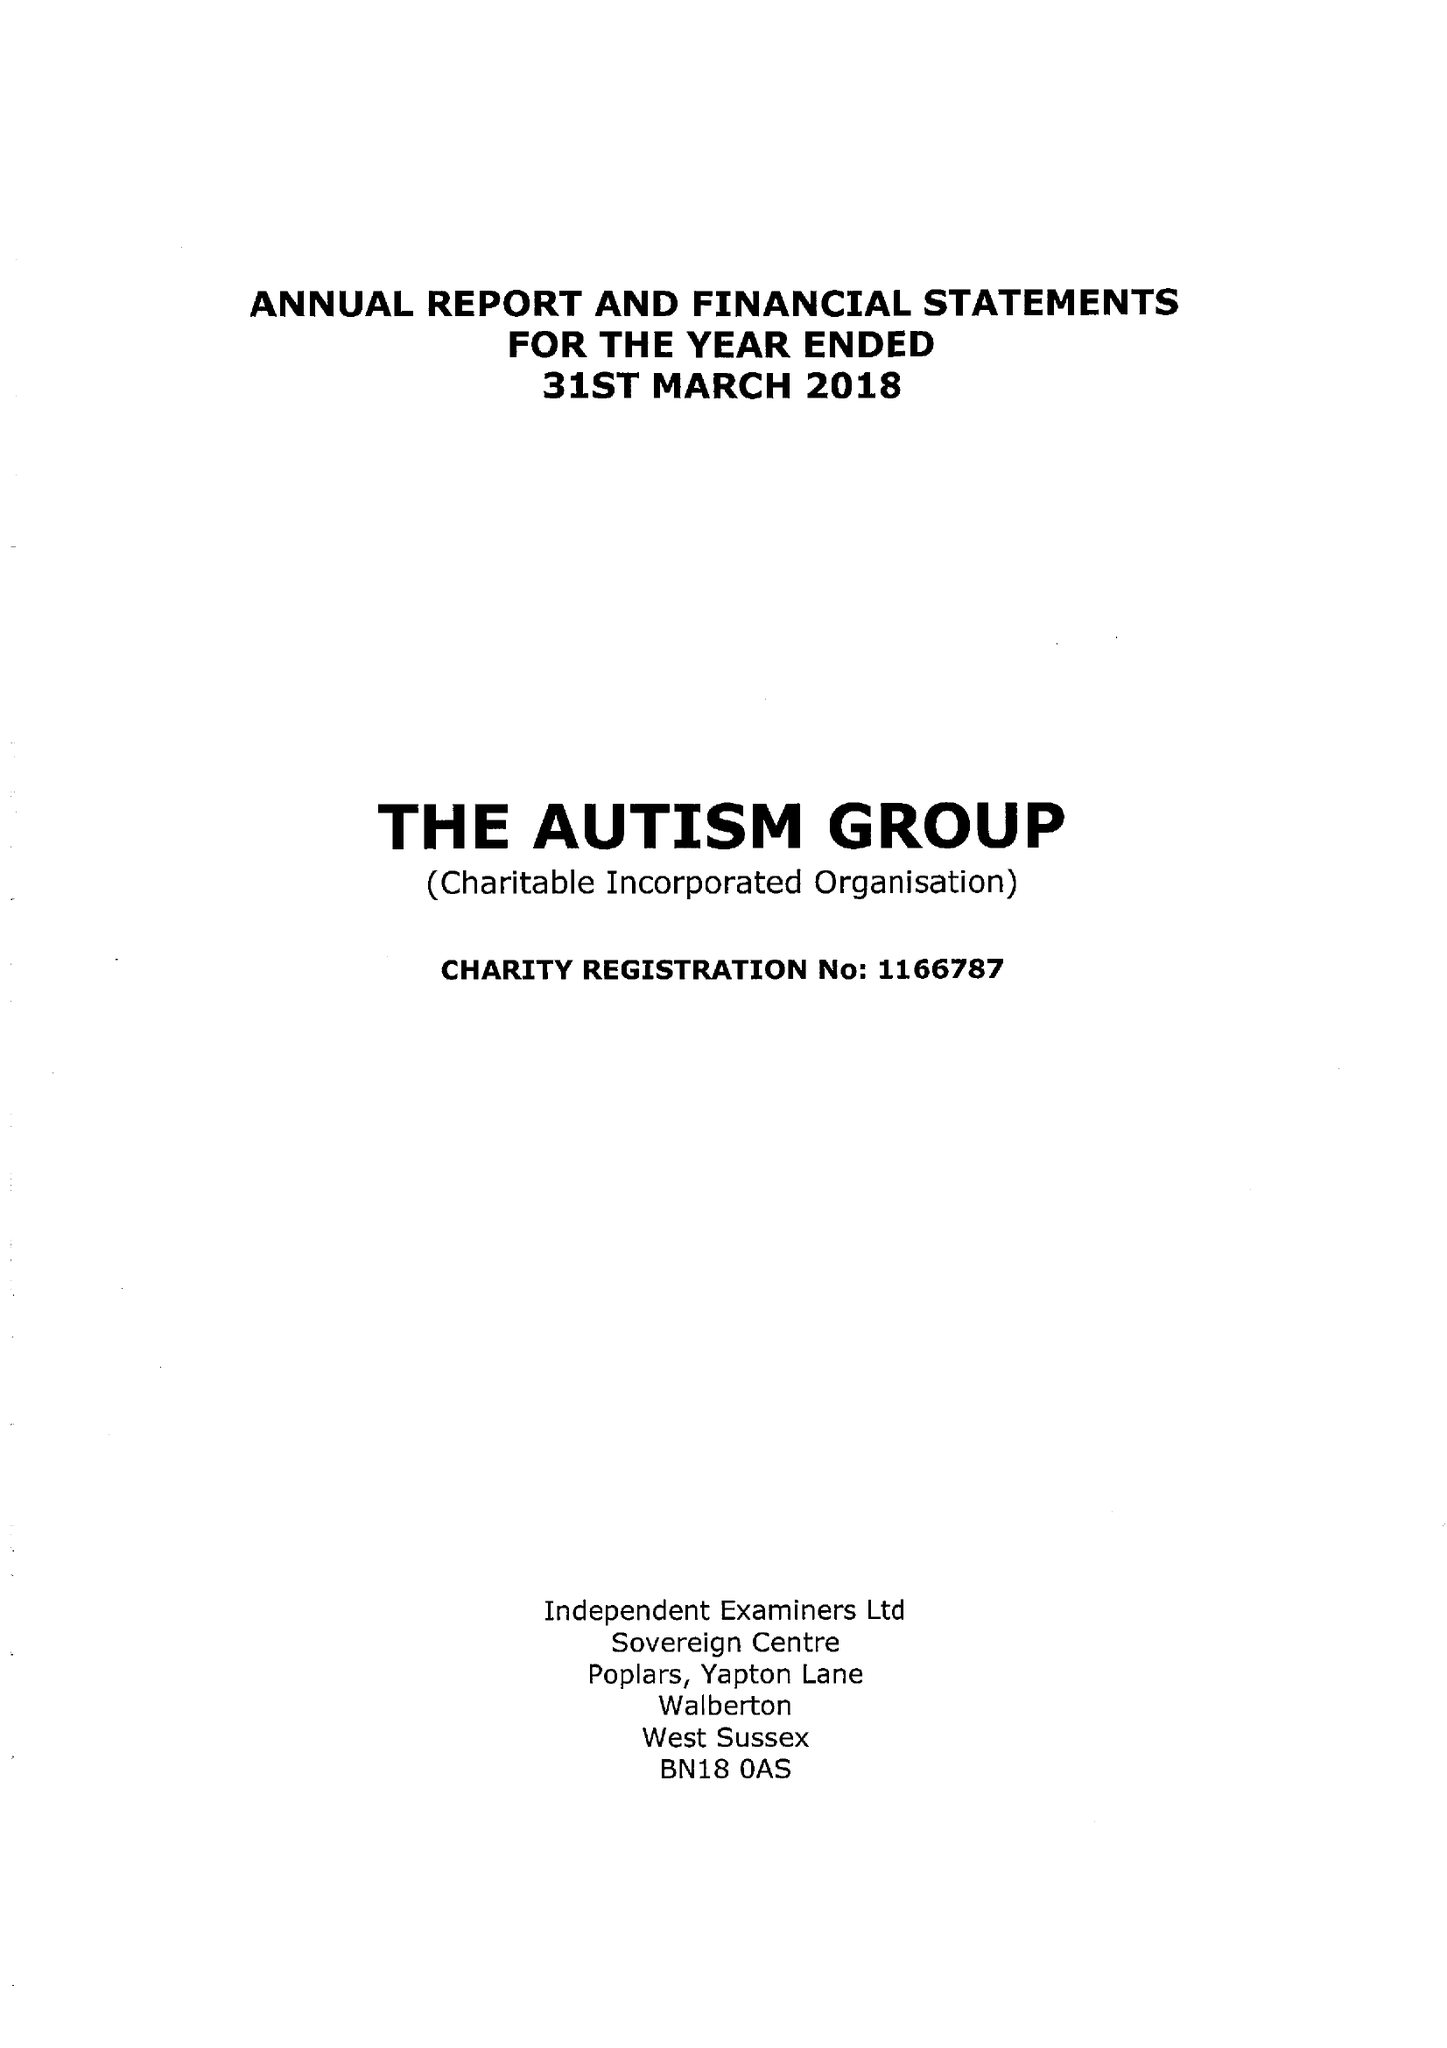What is the value for the address__postcode?
Answer the question using a single word or phrase. SL6 1LY 